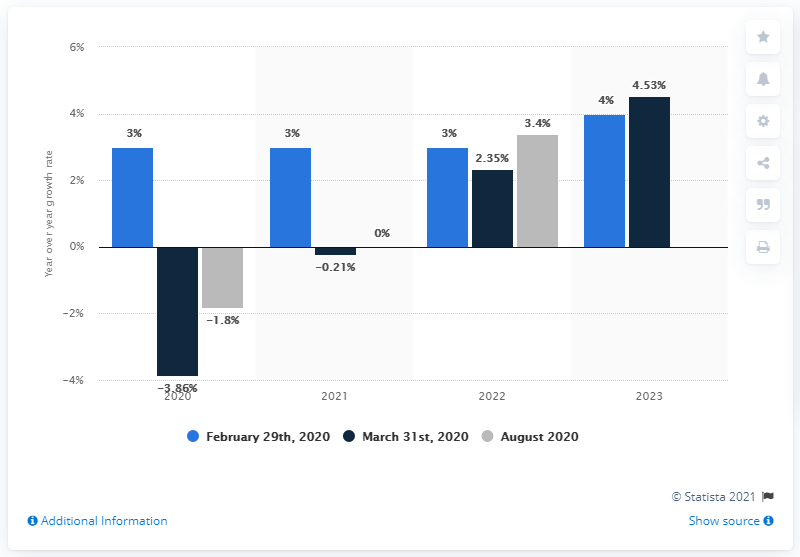List a handful of essential elements in this visual. The European ICT market is not expected to show growth again until 2022. 